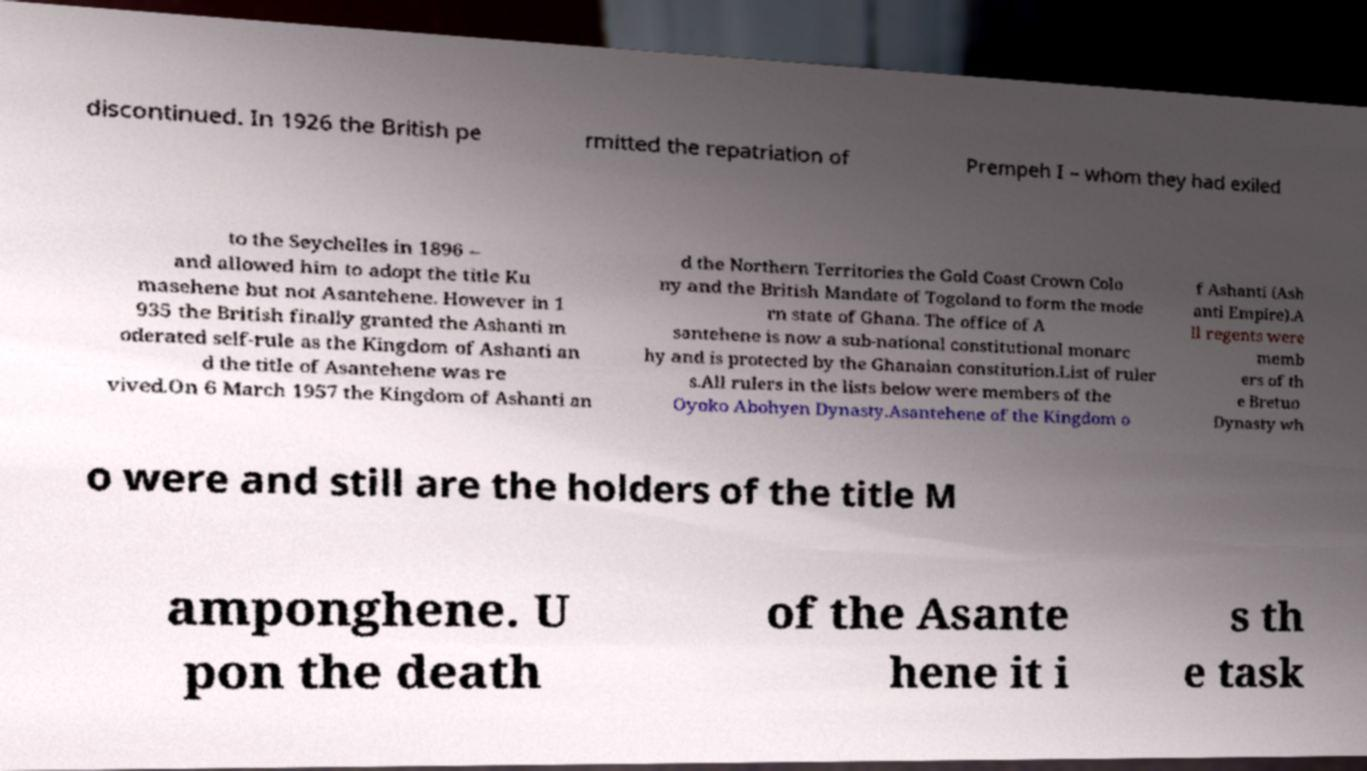For documentation purposes, I need the text within this image transcribed. Could you provide that? discontinued. In 1926 the British pe rmitted the repatriation of Prempeh I – whom they had exiled to the Seychelles in 1896 – and allowed him to adopt the title Ku masehene but not Asantehene. However in 1 935 the British finally granted the Ashanti m oderated self-rule as the Kingdom of Ashanti an d the title of Asantehene was re vived.On 6 March 1957 the Kingdom of Ashanti an d the Northern Territories the Gold Coast Crown Colo ny and the British Mandate of Togoland to form the mode rn state of Ghana. The office of A santehene is now a sub-national constitutional monarc hy and is protected by the Ghanaian constitution.List of ruler s.All rulers in the lists below were members of the Oyoko Abohyen Dynasty.Asantehene of the Kingdom o f Ashanti (Ash anti Empire).A ll regents were memb ers of th e Bretuo Dynasty wh o were and still are the holders of the title M amponghene. U pon the death of the Asante hene it i s th e task 